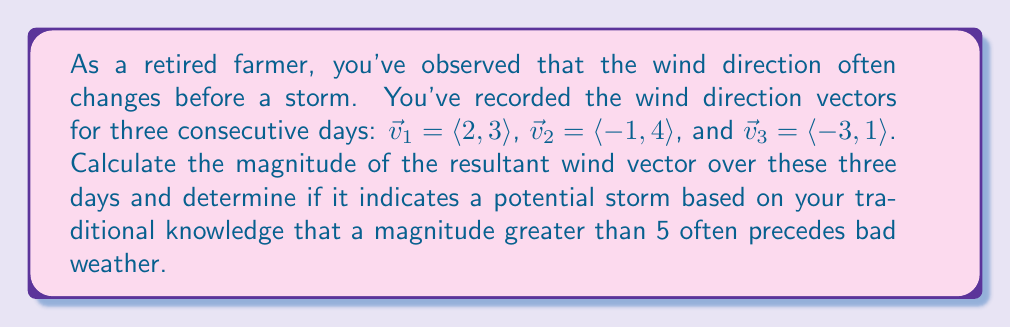Can you solve this math problem? To solve this problem, we'll follow these steps:

1) First, we need to find the resultant wind vector by adding the three daily vectors:

   $\vec{v}_{resultant} = \vec{v}_1 + \vec{v}_2 + \vec{v}_3$

2) Let's perform the vector addition:

   $\vec{v}_{resultant} = \langle 2, 3 \rangle + \langle -1, 4 \rangle + \langle -3, 1 \rangle$
   $= \langle 2 + (-1) + (-3), 3 + 4 + 1 \rangle$
   $= \langle -2, 8 \rangle$

3) Now that we have the resultant vector, we need to calculate its magnitude. The magnitude of a vector $\langle a, b \rangle$ is given by $\sqrt{a^2 + b^2}$.

4) Let's calculate the magnitude:

   $|\vec{v}_{resultant}| = \sqrt{(-2)^2 + 8^2}$
   $= \sqrt{4 + 64}$
   $= \sqrt{68}$
   $\approx 8.25$

5) We compare this magnitude to our threshold of 5:

   $8.25 > 5$

Therefore, based on the traditional knowledge, this wind pattern indicates a potential storm is approaching.
Answer: The magnitude of the resultant wind vector is $\sqrt{68} \approx 8.25$, which is greater than 5, indicating a potential storm according to the traditional method. 